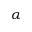Convert formula to latex. <formula><loc_0><loc_0><loc_500><loc_500>\alpha</formula> 